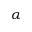Convert formula to latex. <formula><loc_0><loc_0><loc_500><loc_500>\alpha</formula> 